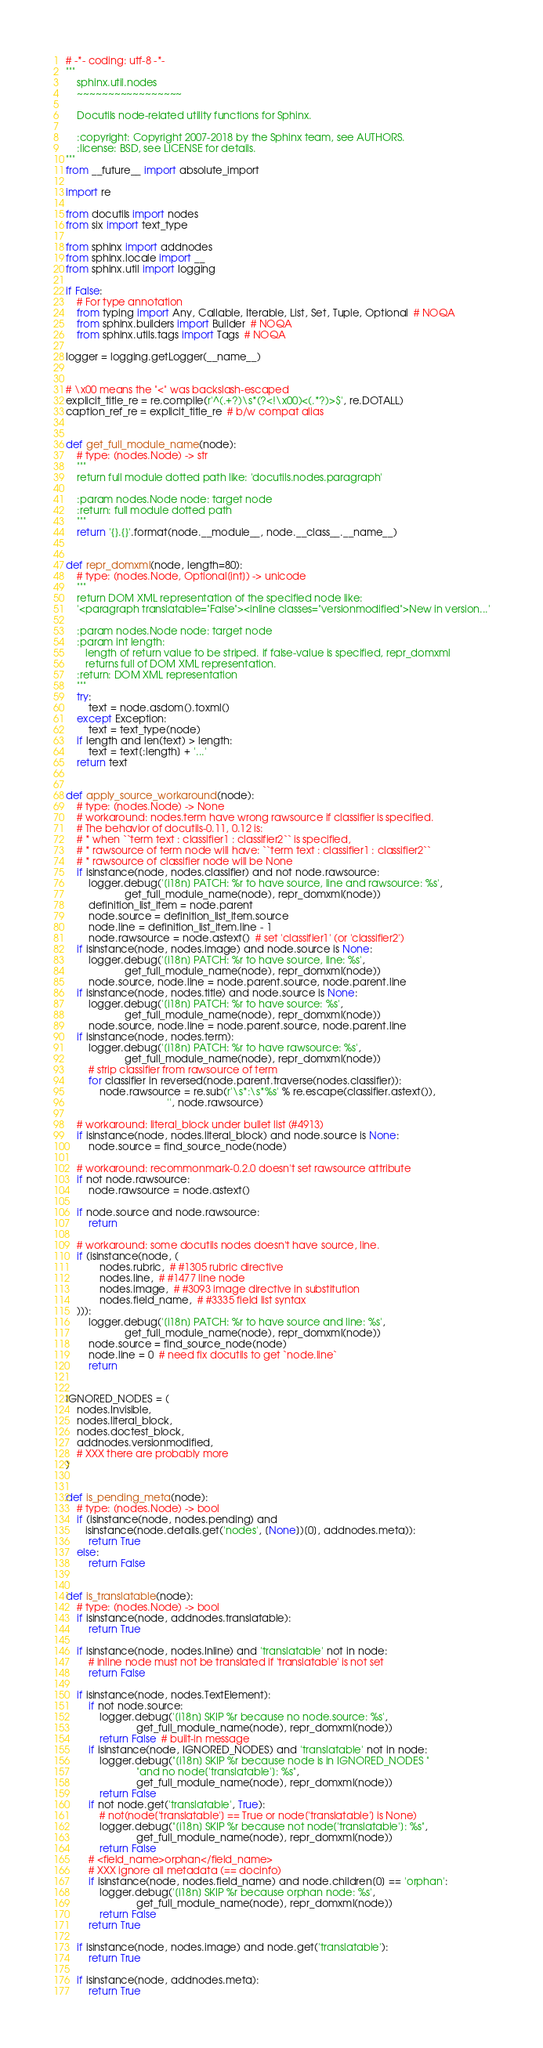<code> <loc_0><loc_0><loc_500><loc_500><_Python_># -*- coding: utf-8 -*-
"""
    sphinx.util.nodes
    ~~~~~~~~~~~~~~~~~

    Docutils node-related utility functions for Sphinx.

    :copyright: Copyright 2007-2018 by the Sphinx team, see AUTHORS.
    :license: BSD, see LICENSE for details.
"""
from __future__ import absolute_import

import re

from docutils import nodes
from six import text_type

from sphinx import addnodes
from sphinx.locale import __
from sphinx.util import logging

if False:
    # For type annotation
    from typing import Any, Callable, Iterable, List, Set, Tuple, Optional  # NOQA
    from sphinx.builders import Builder  # NOQA
    from sphinx.utils.tags import Tags  # NOQA

logger = logging.getLogger(__name__)


# \x00 means the "<" was backslash-escaped
explicit_title_re = re.compile(r'^(.+?)\s*(?<!\x00)<(.*?)>$', re.DOTALL)
caption_ref_re = explicit_title_re  # b/w compat alias


def get_full_module_name(node):
    # type: (nodes.Node) -> str
    """
    return full module dotted path like: 'docutils.nodes.paragraph'

    :param nodes.Node node: target node
    :return: full module dotted path
    """
    return '{}.{}'.format(node.__module__, node.__class__.__name__)


def repr_domxml(node, length=80):
    # type: (nodes.Node, Optional[int]) -> unicode
    """
    return DOM XML representation of the specified node like:
    '<paragraph translatable="False"><inline classes="versionmodified">New in version...'

    :param nodes.Node node: target node
    :param int length:
       length of return value to be striped. if false-value is specified, repr_domxml
       returns full of DOM XML representation.
    :return: DOM XML representation
    """
    try:
        text = node.asdom().toxml()
    except Exception:
        text = text_type(node)
    if length and len(text) > length:
        text = text[:length] + '...'
    return text


def apply_source_workaround(node):
    # type: (nodes.Node) -> None
    # workaround: nodes.term have wrong rawsource if classifier is specified.
    # The behavior of docutils-0.11, 0.12 is:
    # * when ``term text : classifier1 : classifier2`` is specified,
    # * rawsource of term node will have: ``term text : classifier1 : classifier2``
    # * rawsource of classifier node will be None
    if isinstance(node, nodes.classifier) and not node.rawsource:
        logger.debug('[i18n] PATCH: %r to have source, line and rawsource: %s',
                     get_full_module_name(node), repr_domxml(node))
        definition_list_item = node.parent
        node.source = definition_list_item.source
        node.line = definition_list_item.line - 1
        node.rawsource = node.astext()  # set 'classifier1' (or 'classifier2')
    if isinstance(node, nodes.image) and node.source is None:
        logger.debug('[i18n] PATCH: %r to have source, line: %s',
                     get_full_module_name(node), repr_domxml(node))
        node.source, node.line = node.parent.source, node.parent.line
    if isinstance(node, nodes.title) and node.source is None:
        logger.debug('[i18n] PATCH: %r to have source: %s',
                     get_full_module_name(node), repr_domxml(node))
        node.source, node.line = node.parent.source, node.parent.line
    if isinstance(node, nodes.term):
        logger.debug('[i18n] PATCH: %r to have rawsource: %s',
                     get_full_module_name(node), repr_domxml(node))
        # strip classifier from rawsource of term
        for classifier in reversed(node.parent.traverse(nodes.classifier)):
            node.rawsource = re.sub(r'\s*:\s*%s' % re.escape(classifier.astext()),
                                    '', node.rawsource)

    # workaround: literal_block under bullet list (#4913)
    if isinstance(node, nodes.literal_block) and node.source is None:
        node.source = find_source_node(node)

    # workaround: recommonmark-0.2.0 doesn't set rawsource attribute
    if not node.rawsource:
        node.rawsource = node.astext()

    if node.source and node.rawsource:
        return

    # workaround: some docutils nodes doesn't have source, line.
    if (isinstance(node, (
            nodes.rubric,  # #1305 rubric directive
            nodes.line,  # #1477 line node
            nodes.image,  # #3093 image directive in substitution
            nodes.field_name,  # #3335 field list syntax
    ))):
        logger.debug('[i18n] PATCH: %r to have source and line: %s',
                     get_full_module_name(node), repr_domxml(node))
        node.source = find_source_node(node)
        node.line = 0  # need fix docutils to get `node.line`
        return


IGNORED_NODES = (
    nodes.Invisible,
    nodes.literal_block,
    nodes.doctest_block,
    addnodes.versionmodified,
    # XXX there are probably more
)


def is_pending_meta(node):
    # type: (nodes.Node) -> bool
    if (isinstance(node, nodes.pending) and
       isinstance(node.details.get('nodes', [None])[0], addnodes.meta)):
        return True
    else:
        return False


def is_translatable(node):
    # type: (nodes.Node) -> bool
    if isinstance(node, addnodes.translatable):
        return True

    if isinstance(node, nodes.Inline) and 'translatable' not in node:
        # inline node must not be translated if 'translatable' is not set
        return False

    if isinstance(node, nodes.TextElement):
        if not node.source:
            logger.debug('[i18n] SKIP %r because no node.source: %s',
                         get_full_module_name(node), repr_domxml(node))
            return False  # built-in message
        if isinstance(node, IGNORED_NODES) and 'translatable' not in node:
            logger.debug("[i18n] SKIP %r because node is in IGNORED_NODES "
                         "and no node['translatable']: %s",
                         get_full_module_name(node), repr_domxml(node))
            return False
        if not node.get('translatable', True):
            # not(node['translatable'] == True or node['translatable'] is None)
            logger.debug("[i18n] SKIP %r because not node['translatable']: %s",
                         get_full_module_name(node), repr_domxml(node))
            return False
        # <field_name>orphan</field_name>
        # XXX ignore all metadata (== docinfo)
        if isinstance(node, nodes.field_name) and node.children[0] == 'orphan':
            logger.debug('[i18n] SKIP %r because orphan node: %s',
                         get_full_module_name(node), repr_domxml(node))
            return False
        return True

    if isinstance(node, nodes.image) and node.get('translatable'):
        return True

    if isinstance(node, addnodes.meta):
        return True</code> 